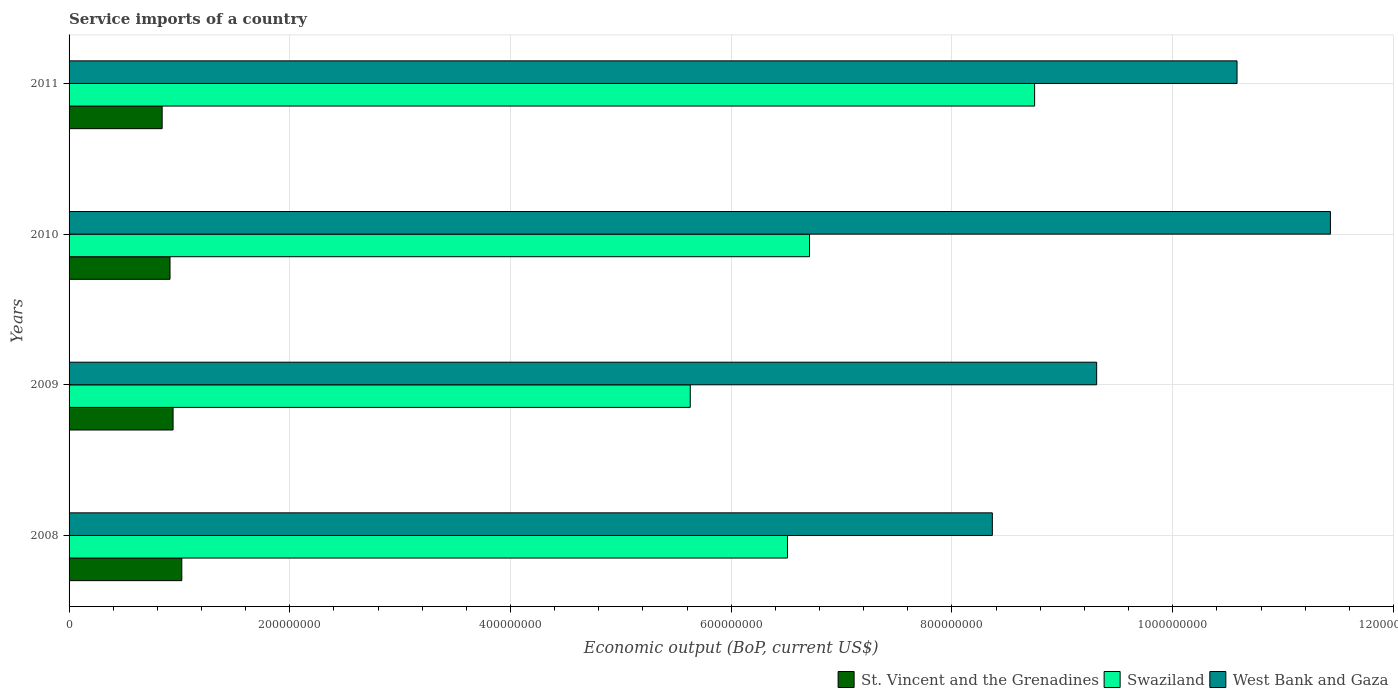How many groups of bars are there?
Offer a terse response. 4. Are the number of bars per tick equal to the number of legend labels?
Your answer should be very brief. Yes. Are the number of bars on each tick of the Y-axis equal?
Your answer should be compact. Yes. How many bars are there on the 1st tick from the top?
Offer a very short reply. 3. How many bars are there on the 3rd tick from the bottom?
Keep it short and to the point. 3. What is the service imports in West Bank and Gaza in 2010?
Ensure brevity in your answer.  1.14e+09. Across all years, what is the maximum service imports in Swaziland?
Your answer should be very brief. 8.75e+08. Across all years, what is the minimum service imports in Swaziland?
Offer a terse response. 5.63e+08. In which year was the service imports in West Bank and Gaza minimum?
Your response must be concise. 2008. What is the total service imports in St. Vincent and the Grenadines in the graph?
Give a very brief answer. 3.72e+08. What is the difference between the service imports in Swaziland in 2008 and that in 2009?
Offer a terse response. 8.81e+07. What is the difference between the service imports in Swaziland in 2009 and the service imports in St. Vincent and the Grenadines in 2008?
Provide a succinct answer. 4.61e+08. What is the average service imports in Swaziland per year?
Offer a very short reply. 6.90e+08. In the year 2011, what is the difference between the service imports in West Bank and Gaza and service imports in St. Vincent and the Grenadines?
Your answer should be very brief. 9.74e+08. What is the ratio of the service imports in Swaziland in 2009 to that in 2011?
Ensure brevity in your answer.  0.64. Is the difference between the service imports in West Bank and Gaza in 2008 and 2010 greater than the difference between the service imports in St. Vincent and the Grenadines in 2008 and 2010?
Your response must be concise. No. What is the difference between the highest and the second highest service imports in West Bank and Gaza?
Your response must be concise. 8.46e+07. What is the difference between the highest and the lowest service imports in St. Vincent and the Grenadines?
Provide a succinct answer. 1.78e+07. Is the sum of the service imports in Swaziland in 2010 and 2011 greater than the maximum service imports in West Bank and Gaza across all years?
Keep it short and to the point. Yes. What does the 2nd bar from the top in 2008 represents?
Your answer should be compact. Swaziland. What does the 2nd bar from the bottom in 2011 represents?
Give a very brief answer. Swaziland. Are all the bars in the graph horizontal?
Ensure brevity in your answer.  Yes. How many years are there in the graph?
Offer a very short reply. 4. What is the difference between two consecutive major ticks on the X-axis?
Your answer should be compact. 2.00e+08. Are the values on the major ticks of X-axis written in scientific E-notation?
Your response must be concise. No. Does the graph contain any zero values?
Your response must be concise. No. Does the graph contain grids?
Keep it short and to the point. Yes. How many legend labels are there?
Provide a succinct answer. 3. How are the legend labels stacked?
Your response must be concise. Horizontal. What is the title of the graph?
Your answer should be very brief. Service imports of a country. Does "Puerto Rico" appear as one of the legend labels in the graph?
Give a very brief answer. No. What is the label or title of the X-axis?
Provide a short and direct response. Economic output (BoP, current US$). What is the Economic output (BoP, current US$) in St. Vincent and the Grenadines in 2008?
Provide a short and direct response. 1.02e+08. What is the Economic output (BoP, current US$) in Swaziland in 2008?
Provide a succinct answer. 6.51e+08. What is the Economic output (BoP, current US$) of West Bank and Gaza in 2008?
Offer a very short reply. 8.37e+08. What is the Economic output (BoP, current US$) in St. Vincent and the Grenadines in 2009?
Provide a short and direct response. 9.42e+07. What is the Economic output (BoP, current US$) of Swaziland in 2009?
Your answer should be very brief. 5.63e+08. What is the Economic output (BoP, current US$) in West Bank and Gaza in 2009?
Offer a very short reply. 9.31e+08. What is the Economic output (BoP, current US$) in St. Vincent and the Grenadines in 2010?
Offer a terse response. 9.15e+07. What is the Economic output (BoP, current US$) in Swaziland in 2010?
Provide a succinct answer. 6.71e+08. What is the Economic output (BoP, current US$) of West Bank and Gaza in 2010?
Offer a very short reply. 1.14e+09. What is the Economic output (BoP, current US$) in St. Vincent and the Grenadines in 2011?
Provide a succinct answer. 8.43e+07. What is the Economic output (BoP, current US$) in Swaziland in 2011?
Your answer should be very brief. 8.75e+08. What is the Economic output (BoP, current US$) in West Bank and Gaza in 2011?
Keep it short and to the point. 1.06e+09. Across all years, what is the maximum Economic output (BoP, current US$) in St. Vincent and the Grenadines?
Provide a short and direct response. 1.02e+08. Across all years, what is the maximum Economic output (BoP, current US$) of Swaziland?
Offer a very short reply. 8.75e+08. Across all years, what is the maximum Economic output (BoP, current US$) in West Bank and Gaza?
Ensure brevity in your answer.  1.14e+09. Across all years, what is the minimum Economic output (BoP, current US$) of St. Vincent and the Grenadines?
Ensure brevity in your answer.  8.43e+07. Across all years, what is the minimum Economic output (BoP, current US$) in Swaziland?
Your answer should be very brief. 5.63e+08. Across all years, what is the minimum Economic output (BoP, current US$) in West Bank and Gaza?
Keep it short and to the point. 8.37e+08. What is the total Economic output (BoP, current US$) of St. Vincent and the Grenadines in the graph?
Provide a short and direct response. 3.72e+08. What is the total Economic output (BoP, current US$) of Swaziland in the graph?
Your answer should be very brief. 2.76e+09. What is the total Economic output (BoP, current US$) of West Bank and Gaza in the graph?
Provide a succinct answer. 3.97e+09. What is the difference between the Economic output (BoP, current US$) of St. Vincent and the Grenadines in 2008 and that in 2009?
Provide a short and direct response. 7.90e+06. What is the difference between the Economic output (BoP, current US$) in Swaziland in 2008 and that in 2009?
Offer a very short reply. 8.81e+07. What is the difference between the Economic output (BoP, current US$) of West Bank and Gaza in 2008 and that in 2009?
Offer a terse response. -9.45e+07. What is the difference between the Economic output (BoP, current US$) in St. Vincent and the Grenadines in 2008 and that in 2010?
Give a very brief answer. 1.07e+07. What is the difference between the Economic output (BoP, current US$) of Swaziland in 2008 and that in 2010?
Make the answer very short. -2.00e+07. What is the difference between the Economic output (BoP, current US$) in West Bank and Gaza in 2008 and that in 2010?
Provide a succinct answer. -3.06e+08. What is the difference between the Economic output (BoP, current US$) in St. Vincent and the Grenadines in 2008 and that in 2011?
Your response must be concise. 1.78e+07. What is the difference between the Economic output (BoP, current US$) in Swaziland in 2008 and that in 2011?
Offer a very short reply. -2.24e+08. What is the difference between the Economic output (BoP, current US$) of West Bank and Gaza in 2008 and that in 2011?
Provide a short and direct response. -2.22e+08. What is the difference between the Economic output (BoP, current US$) of St. Vincent and the Grenadines in 2009 and that in 2010?
Keep it short and to the point. 2.78e+06. What is the difference between the Economic output (BoP, current US$) in Swaziland in 2009 and that in 2010?
Your response must be concise. -1.08e+08. What is the difference between the Economic output (BoP, current US$) of West Bank and Gaza in 2009 and that in 2010?
Your answer should be compact. -2.12e+08. What is the difference between the Economic output (BoP, current US$) in St. Vincent and the Grenadines in 2009 and that in 2011?
Keep it short and to the point. 9.90e+06. What is the difference between the Economic output (BoP, current US$) in Swaziland in 2009 and that in 2011?
Make the answer very short. -3.12e+08. What is the difference between the Economic output (BoP, current US$) of West Bank and Gaza in 2009 and that in 2011?
Offer a terse response. -1.27e+08. What is the difference between the Economic output (BoP, current US$) of St. Vincent and the Grenadines in 2010 and that in 2011?
Give a very brief answer. 7.13e+06. What is the difference between the Economic output (BoP, current US$) in Swaziland in 2010 and that in 2011?
Ensure brevity in your answer.  -2.04e+08. What is the difference between the Economic output (BoP, current US$) in West Bank and Gaza in 2010 and that in 2011?
Your answer should be very brief. 8.46e+07. What is the difference between the Economic output (BoP, current US$) in St. Vincent and the Grenadines in 2008 and the Economic output (BoP, current US$) in Swaziland in 2009?
Give a very brief answer. -4.61e+08. What is the difference between the Economic output (BoP, current US$) in St. Vincent and the Grenadines in 2008 and the Economic output (BoP, current US$) in West Bank and Gaza in 2009?
Your response must be concise. -8.29e+08. What is the difference between the Economic output (BoP, current US$) in Swaziland in 2008 and the Economic output (BoP, current US$) in West Bank and Gaza in 2009?
Your response must be concise. -2.80e+08. What is the difference between the Economic output (BoP, current US$) of St. Vincent and the Grenadines in 2008 and the Economic output (BoP, current US$) of Swaziland in 2010?
Keep it short and to the point. -5.69e+08. What is the difference between the Economic output (BoP, current US$) of St. Vincent and the Grenadines in 2008 and the Economic output (BoP, current US$) of West Bank and Gaza in 2010?
Keep it short and to the point. -1.04e+09. What is the difference between the Economic output (BoP, current US$) of Swaziland in 2008 and the Economic output (BoP, current US$) of West Bank and Gaza in 2010?
Your answer should be very brief. -4.92e+08. What is the difference between the Economic output (BoP, current US$) in St. Vincent and the Grenadines in 2008 and the Economic output (BoP, current US$) in Swaziland in 2011?
Give a very brief answer. -7.73e+08. What is the difference between the Economic output (BoP, current US$) of St. Vincent and the Grenadines in 2008 and the Economic output (BoP, current US$) of West Bank and Gaza in 2011?
Keep it short and to the point. -9.56e+08. What is the difference between the Economic output (BoP, current US$) of Swaziland in 2008 and the Economic output (BoP, current US$) of West Bank and Gaza in 2011?
Offer a very short reply. -4.07e+08. What is the difference between the Economic output (BoP, current US$) in St. Vincent and the Grenadines in 2009 and the Economic output (BoP, current US$) in Swaziland in 2010?
Offer a very short reply. -5.77e+08. What is the difference between the Economic output (BoP, current US$) of St. Vincent and the Grenadines in 2009 and the Economic output (BoP, current US$) of West Bank and Gaza in 2010?
Your response must be concise. -1.05e+09. What is the difference between the Economic output (BoP, current US$) in Swaziland in 2009 and the Economic output (BoP, current US$) in West Bank and Gaza in 2010?
Provide a short and direct response. -5.80e+08. What is the difference between the Economic output (BoP, current US$) in St. Vincent and the Grenadines in 2009 and the Economic output (BoP, current US$) in Swaziland in 2011?
Your answer should be compact. -7.81e+08. What is the difference between the Economic output (BoP, current US$) in St. Vincent and the Grenadines in 2009 and the Economic output (BoP, current US$) in West Bank and Gaza in 2011?
Your response must be concise. -9.64e+08. What is the difference between the Economic output (BoP, current US$) in Swaziland in 2009 and the Economic output (BoP, current US$) in West Bank and Gaza in 2011?
Your answer should be compact. -4.95e+08. What is the difference between the Economic output (BoP, current US$) of St. Vincent and the Grenadines in 2010 and the Economic output (BoP, current US$) of Swaziland in 2011?
Your answer should be very brief. -7.83e+08. What is the difference between the Economic output (BoP, current US$) of St. Vincent and the Grenadines in 2010 and the Economic output (BoP, current US$) of West Bank and Gaza in 2011?
Offer a terse response. -9.67e+08. What is the difference between the Economic output (BoP, current US$) in Swaziland in 2010 and the Economic output (BoP, current US$) in West Bank and Gaza in 2011?
Provide a succinct answer. -3.87e+08. What is the average Economic output (BoP, current US$) in St. Vincent and the Grenadines per year?
Your response must be concise. 9.30e+07. What is the average Economic output (BoP, current US$) of Swaziland per year?
Give a very brief answer. 6.90e+08. What is the average Economic output (BoP, current US$) in West Bank and Gaza per year?
Make the answer very short. 9.92e+08. In the year 2008, what is the difference between the Economic output (BoP, current US$) of St. Vincent and the Grenadines and Economic output (BoP, current US$) of Swaziland?
Provide a succinct answer. -5.49e+08. In the year 2008, what is the difference between the Economic output (BoP, current US$) in St. Vincent and the Grenadines and Economic output (BoP, current US$) in West Bank and Gaza?
Your answer should be compact. -7.34e+08. In the year 2008, what is the difference between the Economic output (BoP, current US$) of Swaziland and Economic output (BoP, current US$) of West Bank and Gaza?
Offer a terse response. -1.86e+08. In the year 2009, what is the difference between the Economic output (BoP, current US$) in St. Vincent and the Grenadines and Economic output (BoP, current US$) in Swaziland?
Provide a succinct answer. -4.69e+08. In the year 2009, what is the difference between the Economic output (BoP, current US$) in St. Vincent and the Grenadines and Economic output (BoP, current US$) in West Bank and Gaza?
Give a very brief answer. -8.37e+08. In the year 2009, what is the difference between the Economic output (BoP, current US$) of Swaziland and Economic output (BoP, current US$) of West Bank and Gaza?
Keep it short and to the point. -3.68e+08. In the year 2010, what is the difference between the Economic output (BoP, current US$) of St. Vincent and the Grenadines and Economic output (BoP, current US$) of Swaziland?
Offer a terse response. -5.79e+08. In the year 2010, what is the difference between the Economic output (BoP, current US$) in St. Vincent and the Grenadines and Economic output (BoP, current US$) in West Bank and Gaza?
Give a very brief answer. -1.05e+09. In the year 2010, what is the difference between the Economic output (BoP, current US$) in Swaziland and Economic output (BoP, current US$) in West Bank and Gaza?
Offer a very short reply. -4.72e+08. In the year 2011, what is the difference between the Economic output (BoP, current US$) of St. Vincent and the Grenadines and Economic output (BoP, current US$) of Swaziland?
Ensure brevity in your answer.  -7.91e+08. In the year 2011, what is the difference between the Economic output (BoP, current US$) of St. Vincent and the Grenadines and Economic output (BoP, current US$) of West Bank and Gaza?
Your response must be concise. -9.74e+08. In the year 2011, what is the difference between the Economic output (BoP, current US$) in Swaziland and Economic output (BoP, current US$) in West Bank and Gaza?
Your answer should be very brief. -1.83e+08. What is the ratio of the Economic output (BoP, current US$) of St. Vincent and the Grenadines in 2008 to that in 2009?
Provide a short and direct response. 1.08. What is the ratio of the Economic output (BoP, current US$) in Swaziland in 2008 to that in 2009?
Your answer should be compact. 1.16. What is the ratio of the Economic output (BoP, current US$) in West Bank and Gaza in 2008 to that in 2009?
Make the answer very short. 0.9. What is the ratio of the Economic output (BoP, current US$) of St. Vincent and the Grenadines in 2008 to that in 2010?
Offer a very short reply. 1.12. What is the ratio of the Economic output (BoP, current US$) of Swaziland in 2008 to that in 2010?
Make the answer very short. 0.97. What is the ratio of the Economic output (BoP, current US$) of West Bank and Gaza in 2008 to that in 2010?
Ensure brevity in your answer.  0.73. What is the ratio of the Economic output (BoP, current US$) in St. Vincent and the Grenadines in 2008 to that in 2011?
Offer a terse response. 1.21. What is the ratio of the Economic output (BoP, current US$) in Swaziland in 2008 to that in 2011?
Provide a short and direct response. 0.74. What is the ratio of the Economic output (BoP, current US$) of West Bank and Gaza in 2008 to that in 2011?
Your answer should be very brief. 0.79. What is the ratio of the Economic output (BoP, current US$) in St. Vincent and the Grenadines in 2009 to that in 2010?
Give a very brief answer. 1.03. What is the ratio of the Economic output (BoP, current US$) in Swaziland in 2009 to that in 2010?
Offer a terse response. 0.84. What is the ratio of the Economic output (BoP, current US$) of West Bank and Gaza in 2009 to that in 2010?
Keep it short and to the point. 0.81. What is the ratio of the Economic output (BoP, current US$) in St. Vincent and the Grenadines in 2009 to that in 2011?
Offer a very short reply. 1.12. What is the ratio of the Economic output (BoP, current US$) of Swaziland in 2009 to that in 2011?
Offer a terse response. 0.64. What is the ratio of the Economic output (BoP, current US$) of West Bank and Gaza in 2009 to that in 2011?
Keep it short and to the point. 0.88. What is the ratio of the Economic output (BoP, current US$) of St. Vincent and the Grenadines in 2010 to that in 2011?
Provide a short and direct response. 1.08. What is the ratio of the Economic output (BoP, current US$) of Swaziland in 2010 to that in 2011?
Give a very brief answer. 0.77. What is the ratio of the Economic output (BoP, current US$) in West Bank and Gaza in 2010 to that in 2011?
Provide a short and direct response. 1.08. What is the difference between the highest and the second highest Economic output (BoP, current US$) of St. Vincent and the Grenadines?
Ensure brevity in your answer.  7.90e+06. What is the difference between the highest and the second highest Economic output (BoP, current US$) in Swaziland?
Your response must be concise. 2.04e+08. What is the difference between the highest and the second highest Economic output (BoP, current US$) of West Bank and Gaza?
Provide a succinct answer. 8.46e+07. What is the difference between the highest and the lowest Economic output (BoP, current US$) in St. Vincent and the Grenadines?
Your answer should be very brief. 1.78e+07. What is the difference between the highest and the lowest Economic output (BoP, current US$) in Swaziland?
Your answer should be very brief. 3.12e+08. What is the difference between the highest and the lowest Economic output (BoP, current US$) of West Bank and Gaza?
Offer a terse response. 3.06e+08. 